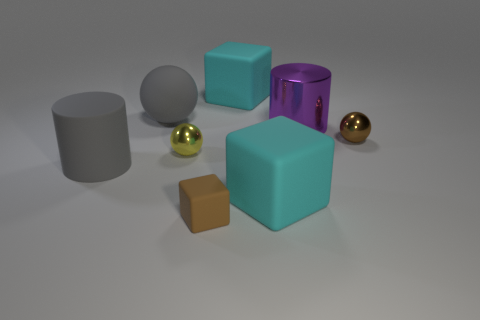Do the matte ball behind the brown metal ball and the matte cylinder have the same color?
Your answer should be compact. Yes. How many other things are the same color as the small block?
Offer a very short reply. 1. What material is the brown cube?
Keep it short and to the point. Rubber. Is the size of the yellow shiny thing that is on the left side of the purple metal cylinder the same as the tiny matte cube?
Ensure brevity in your answer.  Yes. There is a gray thing that is the same shape as the purple thing; what size is it?
Offer a terse response. Large. Are there an equal number of brown cubes that are behind the yellow metal thing and large objects behind the large purple metal cylinder?
Your answer should be compact. No. There is a gray thing that is behind the large purple metal cylinder; what is its size?
Make the answer very short. Large. Do the matte cylinder and the big ball have the same color?
Keep it short and to the point. Yes. What material is the thing that is the same color as the big sphere?
Your answer should be very brief. Rubber. Are there an equal number of large gray rubber spheres on the left side of the large gray matte ball and brown shiny things?
Keep it short and to the point. No. 